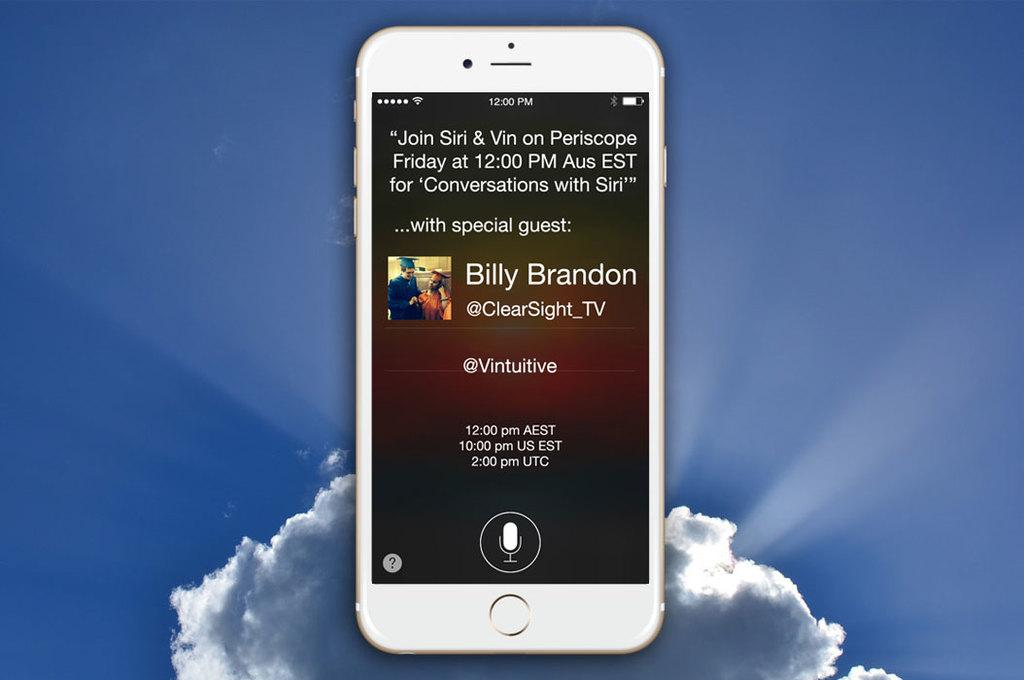<image>
Write a terse but informative summary of the picture. A white iPhone displays a message talking about Siri. 